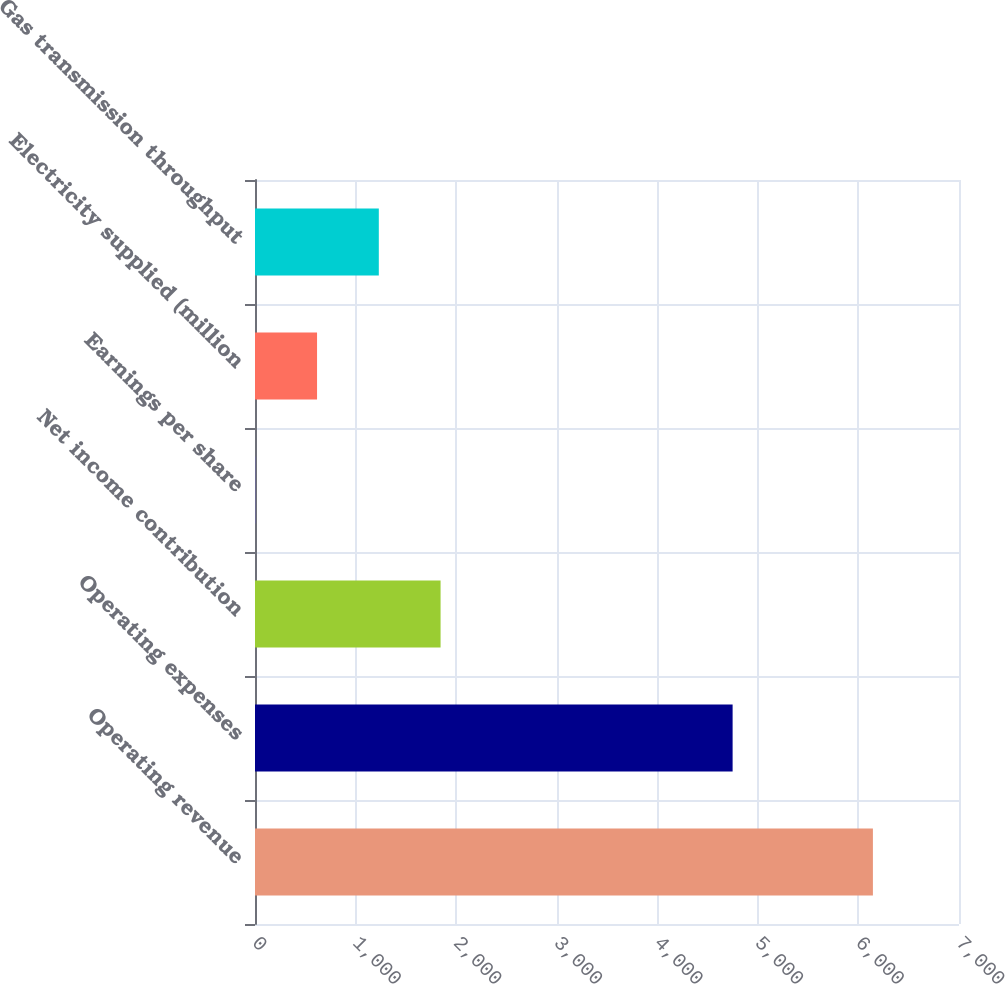Convert chart to OTSL. <chart><loc_0><loc_0><loc_500><loc_500><bar_chart><fcel>Operating revenue<fcel>Operating expenses<fcel>Net income contribution<fcel>Earnings per share<fcel>Electricity supplied (million<fcel>Gas transmission throughput<nl><fcel>6144<fcel>4749<fcel>1845.19<fcel>2.86<fcel>616.97<fcel>1231.08<nl></chart> 